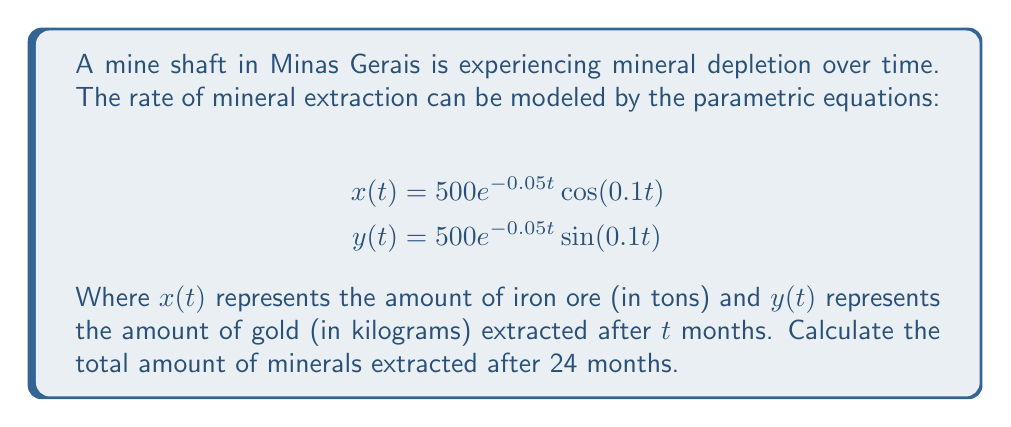Provide a solution to this math problem. To solve this problem, we need to follow these steps:

1) First, we need to calculate $x(24)$ and $y(24)$ by substituting $t=24$ into the given equations.

For $x(24)$:
$$x(24) = 500e^{-0.05(24)}\cos(0.1(24))$$
$$= 500e^{-1.2}\cos(2.4)$$
$$\approx 150.34 \text{ tons of iron ore}$$

For $y(24)$:
$$y(24) = 500e^{-0.05(24)}\sin(0.1(24))$$
$$= 500e^{-1.2}\sin(2.4)$$
$$\approx 127.32 \text{ kg of gold}$$

2) Now, we need to add these values together. However, we can't directly add tons and kilograms. We need to convert one of them.

Let's convert the iron ore to kilograms:
$$150.34 \text{ tons} = 150,340 \text{ kg}$$

3) Now we can add the amounts:
$$150,340 \text{ kg (iron ore)} + 127.32 \text{ kg (gold)} = 150,467.32 \text{ kg}$$

Therefore, the total amount of minerals extracted after 24 months is approximately 150,467.32 kg.
Answer: Approximately 150,467.32 kg of minerals 